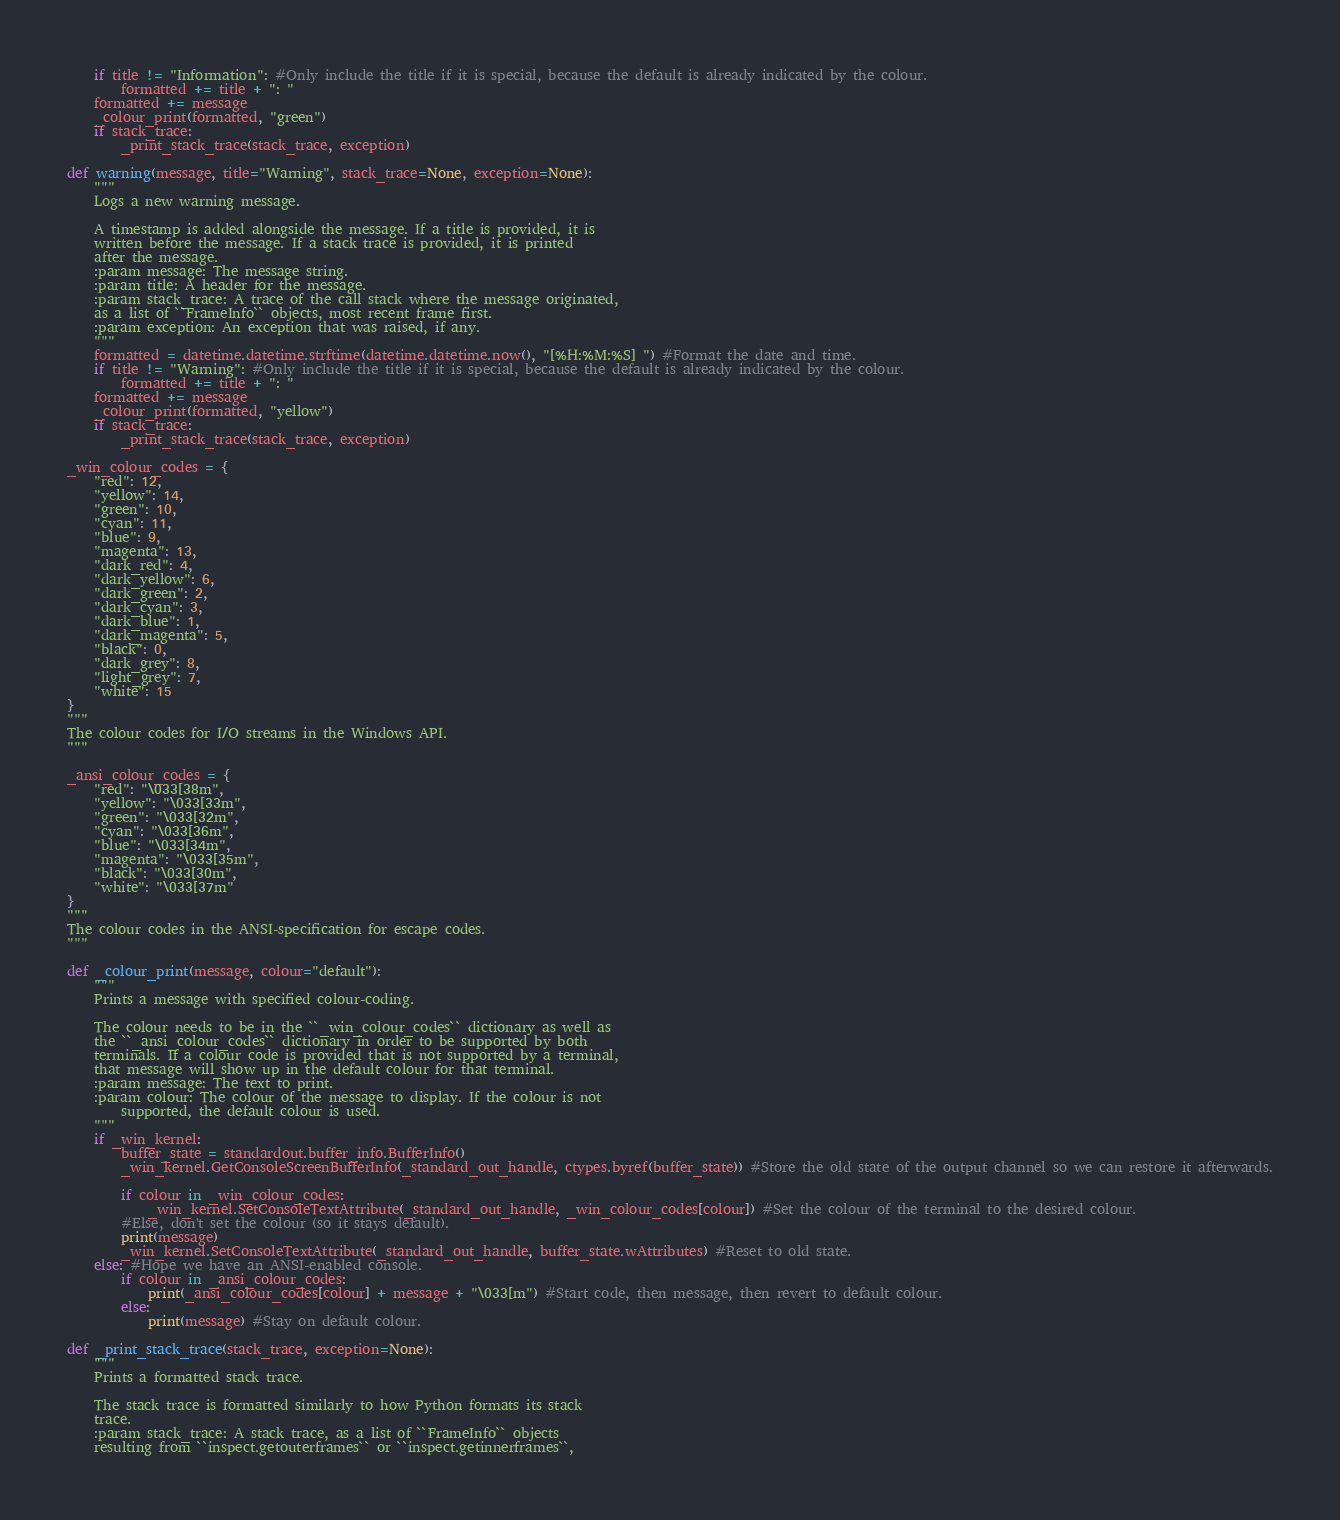<code> <loc_0><loc_0><loc_500><loc_500><_Python_>	if title != "Information": #Only include the title if it is special, because the default is already indicated by the colour.
		formatted += title + ": "
	formatted += message
	_colour_print(formatted, "green")
	if stack_trace:
		_print_stack_trace(stack_trace, exception)

def warning(message, title="Warning", stack_trace=None, exception=None):
	"""
	Logs a new warning message.

	A timestamp is added alongside the message. If a title is provided, it is
	written before the message. If a stack trace is provided, it is printed
	after the message.
	:param message: The message string.
	:param title: A header for the message.
	:param stack_trace: A trace of the call stack where the message originated,
	as a list of ``FrameInfo`` objects, most recent frame first.
	:param exception: An exception that was raised, if any.
	"""
	formatted = datetime.datetime.strftime(datetime.datetime.now(), "[%H:%M:%S] ") #Format the date and time.
	if title != "Warning": #Only include the title if it is special, because the default is already indicated by the colour.
		formatted += title + ": "
	formatted += message
	_colour_print(formatted, "yellow")
	if stack_trace:
		_print_stack_trace(stack_trace, exception)

_win_colour_codes = {
	"red": 12,
	"yellow": 14,
	"green": 10,
	"cyan": 11,
	"blue": 9,
	"magenta": 13,
	"dark_red": 4,
	"dark_yellow": 6,
	"dark_green": 2,
	"dark_cyan": 3,
	"dark_blue": 1,
	"dark_magenta": 5,
	"black": 0,
	"dark_grey": 8,
	"light_grey": 7,
	"white": 15
}
"""
The colour codes for I/O streams in the Windows API.
"""

_ansi_colour_codes = {
	"red": "\033[38m",
	"yellow": "\033[33m",
	"green": "\033[32m",
	"cyan": "\033[36m",
	"blue": "\033[34m",
	"magenta": "\033[35m",
	"black": "\033[30m",
	"white": "\033[37m"
}
"""
The colour codes in the ANSI-specification for escape codes.
"""

def _colour_print(message, colour="default"):
	"""
	Prints a message with specified colour-coding.

	The colour needs to be in the ``_win_colour_codes`` dictionary as well as
	the ``_ansi_colour_codes`` dictionary in order to be supported by both
	terminals. If a colour code is provided that is not supported by a terminal,
	that message will show up in the default colour for that terminal.
	:param message: The text to print.
	:param colour: The colour of the message to display. If the colour is not
		supported, the default colour is used.
	"""
	if _win_kernel:
		buffer_state = standardout.buffer_info.BufferInfo()
		_win_kernel.GetConsoleScreenBufferInfo(_standard_out_handle, ctypes.byref(buffer_state)) #Store the old state of the output channel so we can restore it afterwards.

		if colour in _win_colour_codes:
			_win_kernel.SetConsoleTextAttribute(_standard_out_handle, _win_colour_codes[colour]) #Set the colour of the terminal to the desired colour.
		#Else, don't set the colour (so it stays default).
		print(message)
		_win_kernel.SetConsoleTextAttribute(_standard_out_handle, buffer_state.wAttributes) #Reset to old state.
	else: #Hope we have an ANSI-enabled console.
		if colour in _ansi_colour_codes:
			print(_ansi_colour_codes[colour] + message + "\033[m") #Start code, then message, then revert to default colour.
		else:
			print(message) #Stay on default colour.

def _print_stack_trace(stack_trace, exception=None):
	"""
	Prints a formatted stack trace.

	The stack trace is formatted similarly to how Python formats its stack
	trace.
	:param stack_trace: A stack trace, as a list of ``FrameInfo`` objects
	resulting from ``inspect.getouterframes`` or ``inspect.getinnerframes``,</code> 